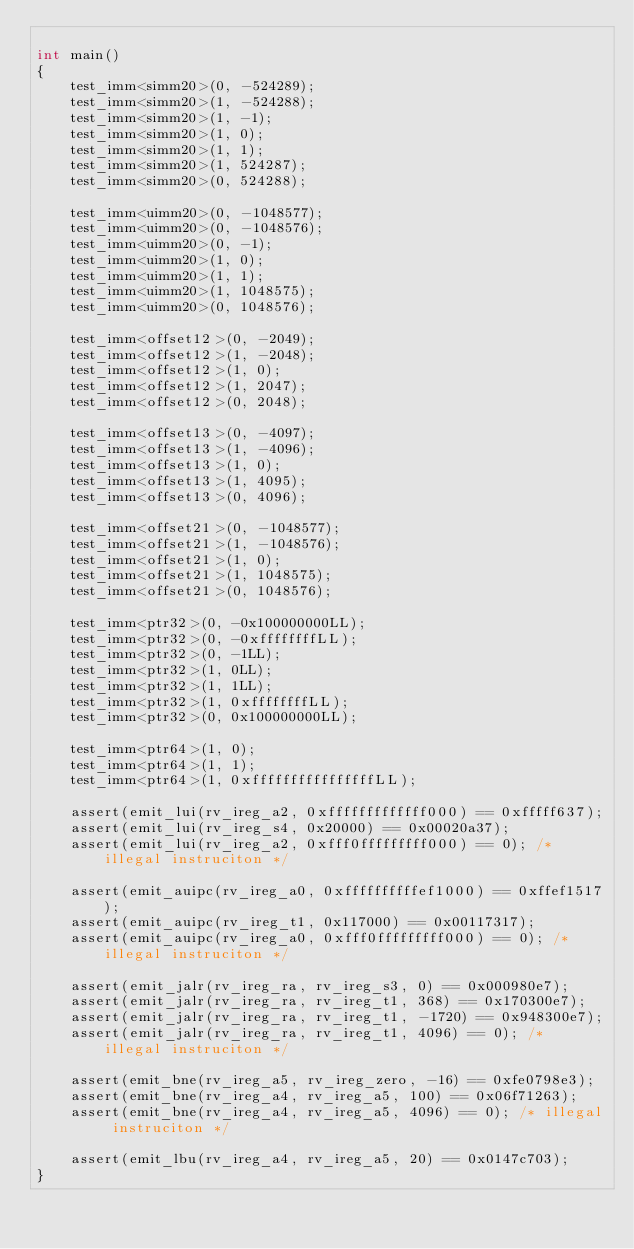<code> <loc_0><loc_0><loc_500><loc_500><_C++_>
int main()
{
	test_imm<simm20>(0, -524289);
	test_imm<simm20>(1, -524288);
	test_imm<simm20>(1, -1);
	test_imm<simm20>(1, 0);
	test_imm<simm20>(1, 1);
	test_imm<simm20>(1, 524287);
	test_imm<simm20>(0, 524288);

	test_imm<uimm20>(0, -1048577);
	test_imm<uimm20>(0, -1048576);
	test_imm<uimm20>(0, -1);
	test_imm<uimm20>(1, 0);
	test_imm<uimm20>(1, 1);
	test_imm<uimm20>(1, 1048575);
	test_imm<uimm20>(0, 1048576);

	test_imm<offset12>(0, -2049);
	test_imm<offset12>(1, -2048);
	test_imm<offset12>(1, 0);
	test_imm<offset12>(1, 2047);
	test_imm<offset12>(0, 2048);

	test_imm<offset13>(0, -4097);
	test_imm<offset13>(1, -4096);
	test_imm<offset13>(1, 0);
	test_imm<offset13>(1, 4095);
	test_imm<offset13>(0, 4096);

	test_imm<offset21>(0, -1048577);
	test_imm<offset21>(1, -1048576);
	test_imm<offset21>(1, 0);
	test_imm<offset21>(1, 1048575);
	test_imm<offset21>(0, 1048576);

	test_imm<ptr32>(0, -0x100000000LL);
	test_imm<ptr32>(0, -0xffffffffLL);
	test_imm<ptr32>(0, -1LL);
	test_imm<ptr32>(1, 0LL);
	test_imm<ptr32>(1, 1LL);
	test_imm<ptr32>(1, 0xffffffffLL);
	test_imm<ptr32>(0, 0x100000000LL);

	test_imm<ptr64>(1, 0);
	test_imm<ptr64>(1, 1);
	test_imm<ptr64>(1, 0xffffffffffffffffLL);

	assert(emit_lui(rv_ireg_a2, 0xfffffffffffff000) == 0xfffff637);
	assert(emit_lui(rv_ireg_s4, 0x20000) == 0x00020a37);
	assert(emit_lui(rv_ireg_a2, 0xfff0fffffffff000) == 0); /* illegal instruciton */

	assert(emit_auipc(rv_ireg_a0, 0xffffffffffef1000) == 0xffef1517);
	assert(emit_auipc(rv_ireg_t1, 0x117000) == 0x00117317);
	assert(emit_auipc(rv_ireg_a0, 0xfff0fffffffff000) == 0); /* illegal instruciton */

	assert(emit_jalr(rv_ireg_ra, rv_ireg_s3, 0) == 0x000980e7);
	assert(emit_jalr(rv_ireg_ra, rv_ireg_t1, 368) == 0x170300e7);
	assert(emit_jalr(rv_ireg_ra, rv_ireg_t1, -1720) == 0x948300e7);
	assert(emit_jalr(rv_ireg_ra, rv_ireg_t1, 4096) == 0); /* illegal instruciton */

	assert(emit_bne(rv_ireg_a5, rv_ireg_zero, -16) == 0xfe0798e3);
	assert(emit_bne(rv_ireg_a4, rv_ireg_a5, 100) == 0x06f71263);
	assert(emit_bne(rv_ireg_a4, rv_ireg_a5, 4096) == 0); /* illegal instruciton */

	assert(emit_lbu(rv_ireg_a4, rv_ireg_a5, 20) == 0x0147c703);
}
</code> 